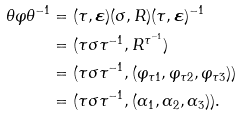Convert formula to latex. <formula><loc_0><loc_0><loc_500><loc_500>\theta \varphi \theta ^ { - 1 } & = ( \tau , \boldsymbol \varepsilon ) ( \sigma , R ) ( \tau , \boldsymbol \varepsilon ) ^ { - 1 } \\ & = ( \tau \sigma \tau ^ { - 1 } , R ^ { \tau ^ { - 1 } } ) \\ & = ( \tau \sigma \tau ^ { - 1 } , ( \varphi _ { \tau 1 } , \varphi _ { \tau 2 } , \varphi _ { \tau 3 } ) ) \\ & = ( \tau \sigma \tau ^ { - 1 } , ( \alpha _ { 1 } , \alpha _ { 2 } , \alpha _ { 3 } ) ) .</formula> 